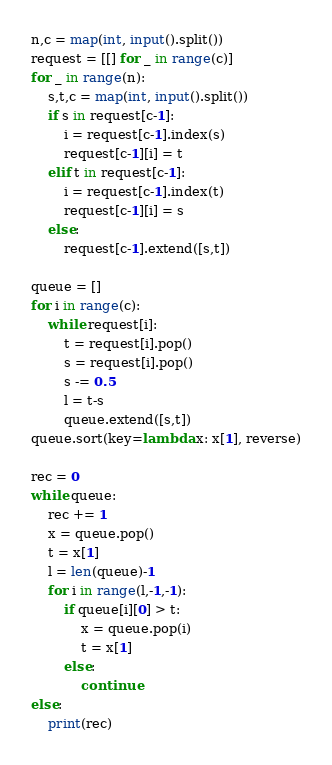<code> <loc_0><loc_0><loc_500><loc_500><_Python_>n,c = map(int, input().split())
request = [[] for _ in range(c)]
for _ in range(n):
    s,t,c = map(int, input().split())
    if s in request[c-1]:
        i = request[c-1].index(s)
        request[c-1][i] = t
    elif t in request[c-1]:
        i = request[c-1].index(t)
        request[c-1][i] = s
    else:
        request[c-1].extend([s,t])

queue = []
for i in range(c):
    while request[i]:
        t = request[i].pop()
        s = request[i].pop()
        s -= 0.5
        l = t-s
        queue.extend([s,t])
queue.sort(key=lambda x: x[1], reverse)

rec = 0
while queue:
    rec += 1
    x = queue.pop()
    t = x[1]
    l = len(queue)-1
    for i in range(l,-1,-1):
        if queue[i][0] > t:
            x = queue.pop(i)
            t = x[1]
        else:
            continue
else:
    print(rec)</code> 